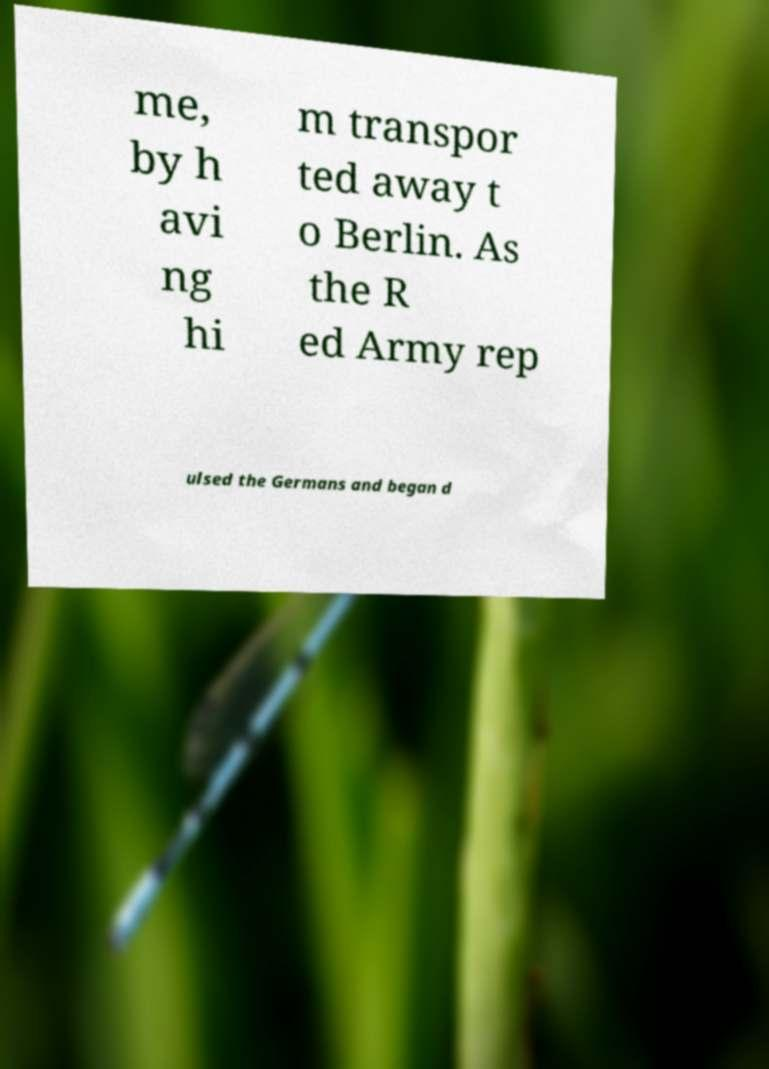Could you assist in decoding the text presented in this image and type it out clearly? me, by h avi ng hi m transpor ted away t o Berlin. As the R ed Army rep ulsed the Germans and began d 